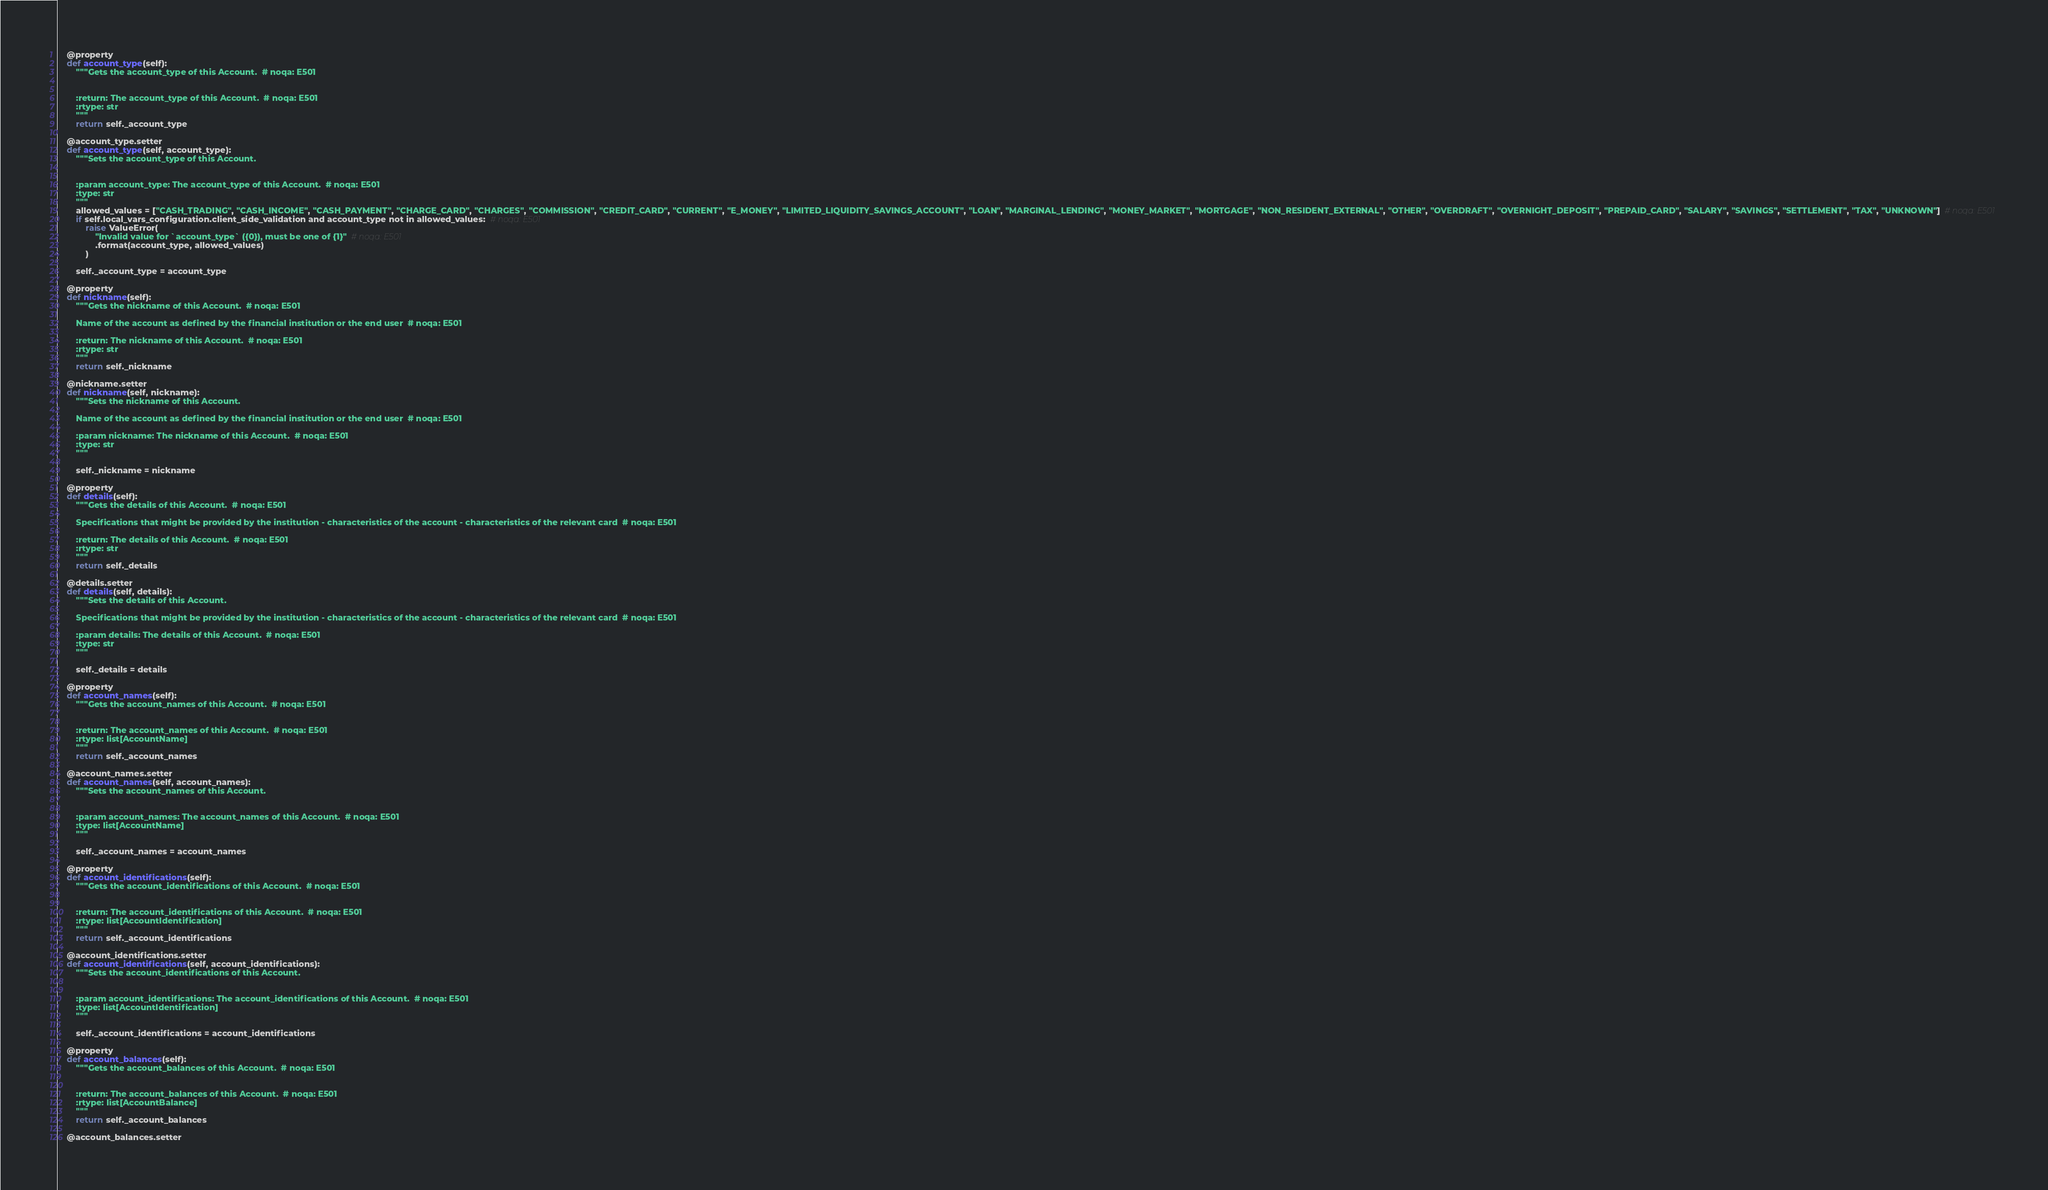<code> <loc_0><loc_0><loc_500><loc_500><_Python_>
    @property
    def account_type(self):
        """Gets the account_type of this Account.  # noqa: E501


        :return: The account_type of this Account.  # noqa: E501
        :rtype: str
        """
        return self._account_type

    @account_type.setter
    def account_type(self, account_type):
        """Sets the account_type of this Account.


        :param account_type: The account_type of this Account.  # noqa: E501
        :type: str
        """
        allowed_values = ["CASH_TRADING", "CASH_INCOME", "CASH_PAYMENT", "CHARGE_CARD", "CHARGES", "COMMISSION", "CREDIT_CARD", "CURRENT", "E_MONEY", "LIMITED_LIQUIDITY_SAVINGS_ACCOUNT", "LOAN", "MARGINAL_LENDING", "MONEY_MARKET", "MORTGAGE", "NON_RESIDENT_EXTERNAL", "OTHER", "OVERDRAFT", "OVERNIGHT_DEPOSIT", "PREPAID_CARD", "SALARY", "SAVINGS", "SETTLEMENT", "TAX", "UNKNOWN"]  # noqa: E501
        if self.local_vars_configuration.client_side_validation and account_type not in allowed_values:  # noqa: E501
            raise ValueError(
                "Invalid value for `account_type` ({0}), must be one of {1}"  # noqa: E501
                .format(account_type, allowed_values)
            )

        self._account_type = account_type

    @property
    def nickname(self):
        """Gets the nickname of this Account.  # noqa: E501

        Name of the account as defined by the financial institution or the end user  # noqa: E501

        :return: The nickname of this Account.  # noqa: E501
        :rtype: str
        """
        return self._nickname

    @nickname.setter
    def nickname(self, nickname):
        """Sets the nickname of this Account.

        Name of the account as defined by the financial institution or the end user  # noqa: E501

        :param nickname: The nickname of this Account.  # noqa: E501
        :type: str
        """

        self._nickname = nickname

    @property
    def details(self):
        """Gets the details of this Account.  # noqa: E501

        Specifications that might be provided by the institution - characteristics of the account - characteristics of the relevant card  # noqa: E501

        :return: The details of this Account.  # noqa: E501
        :rtype: str
        """
        return self._details

    @details.setter
    def details(self, details):
        """Sets the details of this Account.

        Specifications that might be provided by the institution - characteristics of the account - characteristics of the relevant card  # noqa: E501

        :param details: The details of this Account.  # noqa: E501
        :type: str
        """

        self._details = details

    @property
    def account_names(self):
        """Gets the account_names of this Account.  # noqa: E501


        :return: The account_names of this Account.  # noqa: E501
        :rtype: list[AccountName]
        """
        return self._account_names

    @account_names.setter
    def account_names(self, account_names):
        """Sets the account_names of this Account.


        :param account_names: The account_names of this Account.  # noqa: E501
        :type: list[AccountName]
        """

        self._account_names = account_names

    @property
    def account_identifications(self):
        """Gets the account_identifications of this Account.  # noqa: E501


        :return: The account_identifications of this Account.  # noqa: E501
        :rtype: list[AccountIdentification]
        """
        return self._account_identifications

    @account_identifications.setter
    def account_identifications(self, account_identifications):
        """Sets the account_identifications of this Account.


        :param account_identifications: The account_identifications of this Account.  # noqa: E501
        :type: list[AccountIdentification]
        """

        self._account_identifications = account_identifications

    @property
    def account_balances(self):
        """Gets the account_balances of this Account.  # noqa: E501


        :return: The account_balances of this Account.  # noqa: E501
        :rtype: list[AccountBalance]
        """
        return self._account_balances

    @account_balances.setter</code> 